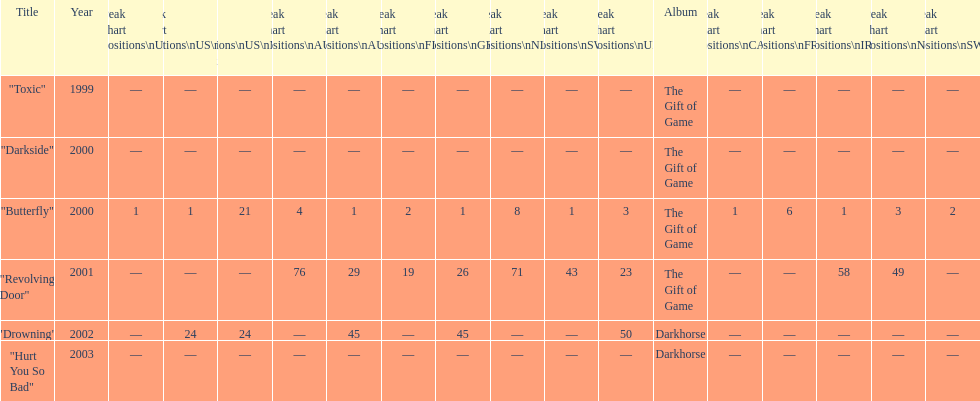Could you parse the entire table as a dict? {'header': ['Title', 'Year', 'Peak chart positions\\nUS', 'Peak chart positions\\nUS\\nAlt.', 'Peak chart positions\\nUS\\nMain. Rock', 'Peak chart positions\\nAUS', 'Peak chart positions\\nAUT', 'Peak chart positions\\nFIN', 'Peak chart positions\\nGER', 'Peak chart positions\\nNLD', 'Peak chart positions\\nSWI', 'Peak chart positions\\nUK', 'Album', 'Peak chart positions\\nCAN', 'Peak chart positions\\nFRA', 'Peak chart positions\\nIRE', 'Peak chart positions\\nNZ', 'Peak chart positions\\nSWE'], 'rows': [['"Toxic"', '1999', '—', '—', '—', '—', '—', '—', '—', '—', '—', '—', 'The Gift of Game', '—', '—', '—', '—', '—'], ['"Darkside"', '2000', '—', '—', '—', '—', '—', '—', '—', '—', '—', '—', 'The Gift of Game', '—', '—', '—', '—', '—'], ['"Butterfly"', '2000', '1', '1', '21', '4', '1', '2', '1', '8', '1', '3', 'The Gift of Game', '1', '6', '1', '3', '2'], ['"Revolving Door"', '2001', '—', '—', '—', '76', '29', '19', '26', '71', '43', '23', 'The Gift of Game', '—', '—', '58', '49', '—'], ['"Drowning"', '2002', '—', '24', '24', '—', '45', '—', '45', '—', '—', '50', 'Darkhorse', '—', '—', '—', '—', '—'], ['"Hurt You So Bad"', '2003', '—', '—', '—', '—', '—', '—', '—', '—', '—', '—', 'Darkhorse', '—', '—', '—', '—', '—']]} How many times did the single "butterfly" rank as 1 in the chart? 5. 